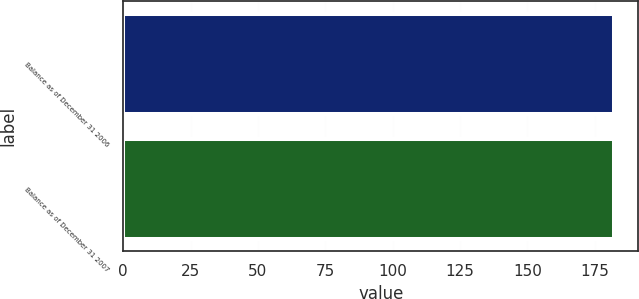<chart> <loc_0><loc_0><loc_500><loc_500><bar_chart><fcel>Balance as of December 31 2006<fcel>Balance as of December 31 2007<nl><fcel>182<fcel>182.1<nl></chart> 